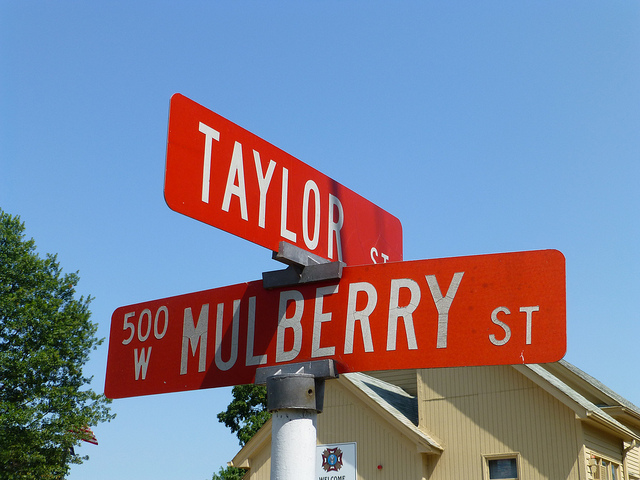Please transcribe the text in this image. TAYLOR MULBERRY ST 500 W 